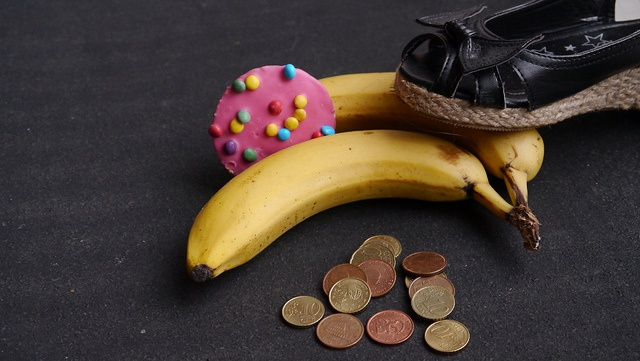Describe the objects in this image and their specific colors. I can see a banana in black, tan, olive, and khaki tones in this image. 